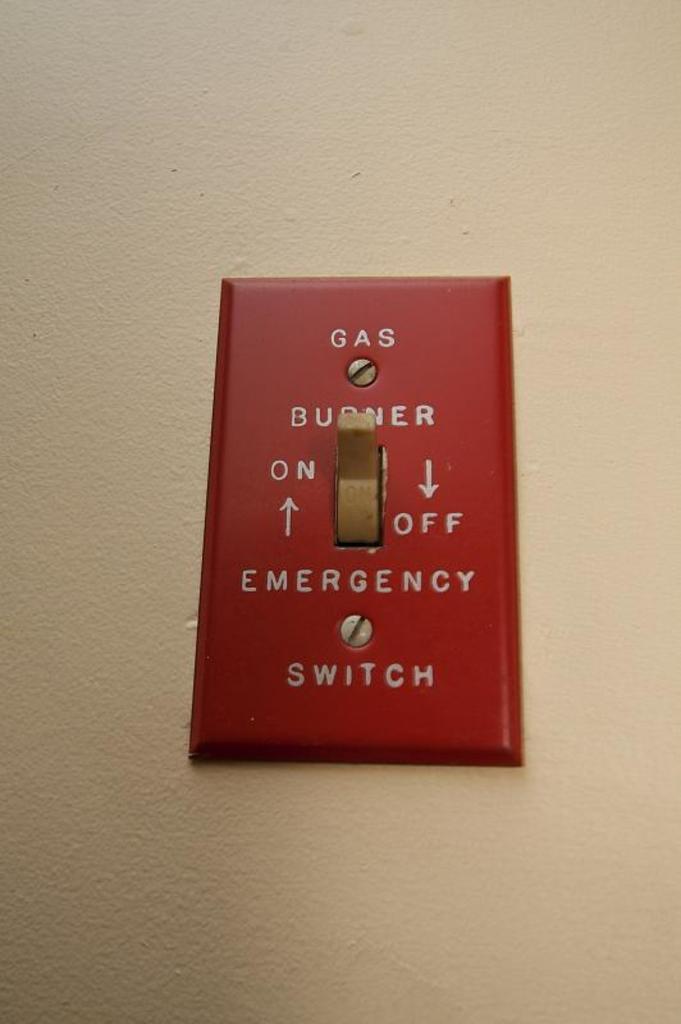What kind of switch is this?
Your answer should be compact. Emergency switch. What type of word is printed on the top of the red switch?
Offer a very short reply. Gas. 